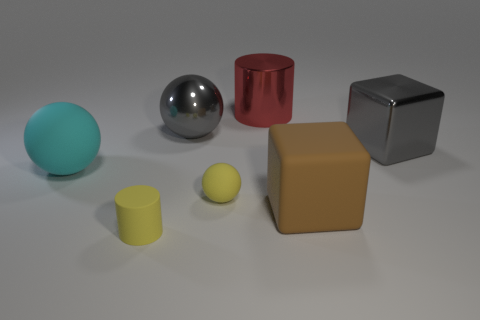Subtract all gray metallic spheres. How many spheres are left? 2 Subtract all yellow spheres. How many spheres are left? 2 Add 2 red metal things. How many objects exist? 9 Subtract all cylinders. How many objects are left? 5 Add 1 rubber cubes. How many rubber cubes exist? 2 Subtract 0 green cylinders. How many objects are left? 7 Subtract 2 cylinders. How many cylinders are left? 0 Subtract all gray blocks. Subtract all red cylinders. How many blocks are left? 1 Subtract all purple cylinders. How many brown cubes are left? 1 Subtract all big brown cubes. Subtract all large gray metal balls. How many objects are left? 5 